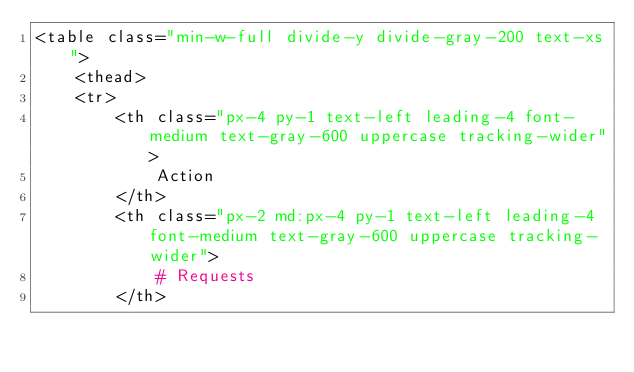Convert code to text. <code><loc_0><loc_0><loc_500><loc_500><_PHP_><table class="min-w-full divide-y divide-gray-200 text-xs">
    <thead>
    <tr>
        <th class="px-4 py-1 text-left leading-4 font-medium text-gray-600 uppercase tracking-wider">
            Action
        </th>
        <th class="px-2 md:px-4 py-1 text-left leading-4 font-medium text-gray-600 uppercase tracking-wider">
            # Requests
        </th></code> 